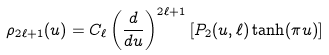Convert formula to latex. <formula><loc_0><loc_0><loc_500><loc_500>\rho _ { 2 \ell + 1 } ( u ) = C _ { \ell } \left ( \frac { d } { d u } \right ) ^ { 2 \ell + 1 } \left [ P _ { 2 } ( u , \ell ) \tanh ( \pi u ) \right ]</formula> 